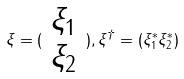Convert formula to latex. <formula><loc_0><loc_0><loc_500><loc_500>\xi = ( \begin{array} { c } \xi _ { 1 } \\ \xi _ { 2 } \end{array} ) , \xi ^ { \dag } = ( \xi _ { 1 } ^ { * } \xi _ { 2 } ^ { * } )</formula> 